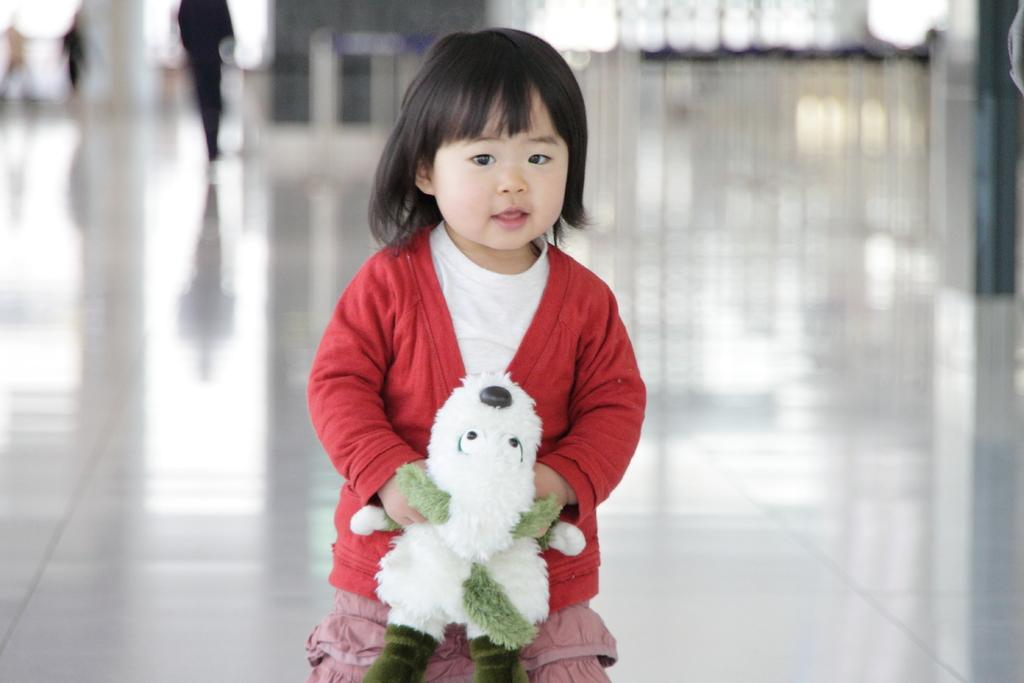Who is the main subject in the image? There is a girl in the image. What is the girl holding in her hand? The girl is holding a soft toy in her hand. Can you describe the background of the image? The background of the image is blurred. What type of crow can be seen interacting with the deer in the image? There is no crow or deer present in the image; it features a girl holding a soft toy. What is the girl's desire in the image? The image does not provide information about the girl's desires or emotions. 